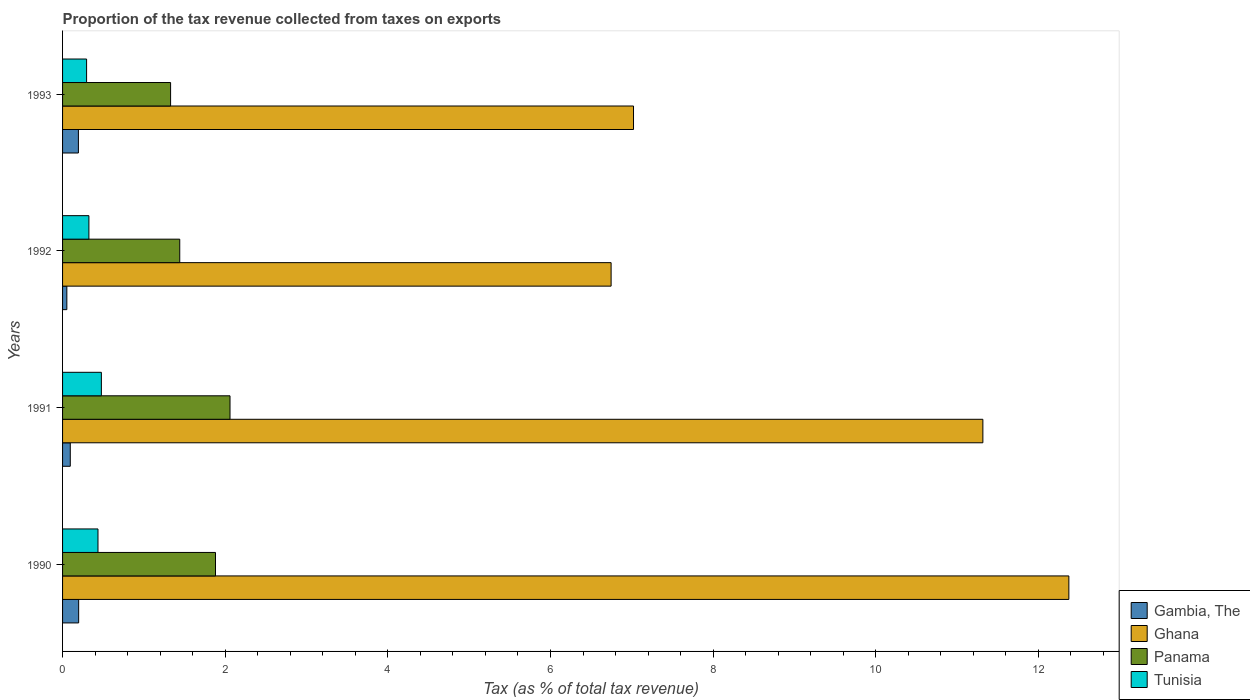Are the number of bars per tick equal to the number of legend labels?
Offer a very short reply. Yes. Are the number of bars on each tick of the Y-axis equal?
Your answer should be very brief. Yes. What is the proportion of the tax revenue collected in Ghana in 1993?
Ensure brevity in your answer.  7.02. Across all years, what is the maximum proportion of the tax revenue collected in Gambia, The?
Your answer should be compact. 0.2. Across all years, what is the minimum proportion of the tax revenue collected in Gambia, The?
Give a very brief answer. 0.05. In which year was the proportion of the tax revenue collected in Gambia, The maximum?
Your answer should be very brief. 1990. In which year was the proportion of the tax revenue collected in Gambia, The minimum?
Keep it short and to the point. 1992. What is the total proportion of the tax revenue collected in Tunisia in the graph?
Offer a terse response. 1.53. What is the difference between the proportion of the tax revenue collected in Panama in 1990 and that in 1993?
Your response must be concise. 0.55. What is the difference between the proportion of the tax revenue collected in Ghana in 1990 and the proportion of the tax revenue collected in Panama in 1992?
Keep it short and to the point. 10.93. What is the average proportion of the tax revenue collected in Panama per year?
Offer a very short reply. 1.68. In the year 1990, what is the difference between the proportion of the tax revenue collected in Gambia, The and proportion of the tax revenue collected in Panama?
Keep it short and to the point. -1.68. In how many years, is the proportion of the tax revenue collected in Panama greater than 8.4 %?
Keep it short and to the point. 0. What is the ratio of the proportion of the tax revenue collected in Ghana in 1990 to that in 1992?
Offer a very short reply. 1.83. Is the proportion of the tax revenue collected in Ghana in 1990 less than that in 1991?
Give a very brief answer. No. Is the difference between the proportion of the tax revenue collected in Gambia, The in 1990 and 1993 greater than the difference between the proportion of the tax revenue collected in Panama in 1990 and 1993?
Keep it short and to the point. No. What is the difference between the highest and the second highest proportion of the tax revenue collected in Ghana?
Provide a succinct answer. 1.06. What is the difference between the highest and the lowest proportion of the tax revenue collected in Ghana?
Your answer should be compact. 5.63. Is the sum of the proportion of the tax revenue collected in Gambia, The in 1990 and 1992 greater than the maximum proportion of the tax revenue collected in Panama across all years?
Give a very brief answer. No. What does the 2nd bar from the top in 1991 represents?
Your response must be concise. Panama. What does the 4th bar from the bottom in 1992 represents?
Provide a short and direct response. Tunisia. How many bars are there?
Your response must be concise. 16. Are all the bars in the graph horizontal?
Offer a very short reply. Yes. What is the difference between two consecutive major ticks on the X-axis?
Your answer should be compact. 2. How are the legend labels stacked?
Make the answer very short. Vertical. What is the title of the graph?
Ensure brevity in your answer.  Proportion of the tax revenue collected from taxes on exports. Does "South Sudan" appear as one of the legend labels in the graph?
Provide a succinct answer. No. What is the label or title of the X-axis?
Your answer should be very brief. Tax (as % of total tax revenue). What is the Tax (as % of total tax revenue) of Gambia, The in 1990?
Provide a short and direct response. 0.2. What is the Tax (as % of total tax revenue) in Ghana in 1990?
Your answer should be very brief. 12.37. What is the Tax (as % of total tax revenue) in Panama in 1990?
Keep it short and to the point. 1.88. What is the Tax (as % of total tax revenue) in Tunisia in 1990?
Your response must be concise. 0.44. What is the Tax (as % of total tax revenue) of Gambia, The in 1991?
Give a very brief answer. 0.09. What is the Tax (as % of total tax revenue) in Ghana in 1991?
Your answer should be compact. 11.32. What is the Tax (as % of total tax revenue) in Panama in 1991?
Your answer should be very brief. 2.06. What is the Tax (as % of total tax revenue) of Tunisia in 1991?
Provide a short and direct response. 0.48. What is the Tax (as % of total tax revenue) in Gambia, The in 1992?
Make the answer very short. 0.05. What is the Tax (as % of total tax revenue) of Ghana in 1992?
Provide a succinct answer. 6.75. What is the Tax (as % of total tax revenue) of Panama in 1992?
Your response must be concise. 1.44. What is the Tax (as % of total tax revenue) in Tunisia in 1992?
Offer a very short reply. 0.32. What is the Tax (as % of total tax revenue) in Gambia, The in 1993?
Offer a very short reply. 0.19. What is the Tax (as % of total tax revenue) of Ghana in 1993?
Give a very brief answer. 7.02. What is the Tax (as % of total tax revenue) of Panama in 1993?
Give a very brief answer. 1.33. What is the Tax (as % of total tax revenue) of Tunisia in 1993?
Give a very brief answer. 0.3. Across all years, what is the maximum Tax (as % of total tax revenue) of Gambia, The?
Your answer should be compact. 0.2. Across all years, what is the maximum Tax (as % of total tax revenue) of Ghana?
Offer a very short reply. 12.37. Across all years, what is the maximum Tax (as % of total tax revenue) in Panama?
Keep it short and to the point. 2.06. Across all years, what is the maximum Tax (as % of total tax revenue) of Tunisia?
Your answer should be very brief. 0.48. Across all years, what is the minimum Tax (as % of total tax revenue) of Gambia, The?
Your answer should be very brief. 0.05. Across all years, what is the minimum Tax (as % of total tax revenue) in Ghana?
Provide a short and direct response. 6.75. Across all years, what is the minimum Tax (as % of total tax revenue) of Panama?
Your answer should be compact. 1.33. Across all years, what is the minimum Tax (as % of total tax revenue) in Tunisia?
Offer a very short reply. 0.3. What is the total Tax (as % of total tax revenue) in Gambia, The in the graph?
Offer a very short reply. 0.54. What is the total Tax (as % of total tax revenue) of Ghana in the graph?
Provide a succinct answer. 37.46. What is the total Tax (as % of total tax revenue) in Panama in the graph?
Keep it short and to the point. 6.71. What is the total Tax (as % of total tax revenue) of Tunisia in the graph?
Your answer should be compact. 1.53. What is the difference between the Tax (as % of total tax revenue) in Gambia, The in 1990 and that in 1991?
Keep it short and to the point. 0.1. What is the difference between the Tax (as % of total tax revenue) in Ghana in 1990 and that in 1991?
Give a very brief answer. 1.06. What is the difference between the Tax (as % of total tax revenue) of Panama in 1990 and that in 1991?
Your answer should be very brief. -0.18. What is the difference between the Tax (as % of total tax revenue) of Tunisia in 1990 and that in 1991?
Provide a short and direct response. -0.04. What is the difference between the Tax (as % of total tax revenue) of Gambia, The in 1990 and that in 1992?
Your answer should be very brief. 0.15. What is the difference between the Tax (as % of total tax revenue) of Ghana in 1990 and that in 1992?
Your response must be concise. 5.63. What is the difference between the Tax (as % of total tax revenue) of Panama in 1990 and that in 1992?
Make the answer very short. 0.44. What is the difference between the Tax (as % of total tax revenue) in Tunisia in 1990 and that in 1992?
Provide a short and direct response. 0.11. What is the difference between the Tax (as % of total tax revenue) in Gambia, The in 1990 and that in 1993?
Your answer should be compact. 0. What is the difference between the Tax (as % of total tax revenue) of Ghana in 1990 and that in 1993?
Keep it short and to the point. 5.35. What is the difference between the Tax (as % of total tax revenue) in Panama in 1990 and that in 1993?
Your answer should be very brief. 0.55. What is the difference between the Tax (as % of total tax revenue) of Tunisia in 1990 and that in 1993?
Give a very brief answer. 0.14. What is the difference between the Tax (as % of total tax revenue) of Gambia, The in 1991 and that in 1992?
Your answer should be compact. 0.04. What is the difference between the Tax (as % of total tax revenue) in Ghana in 1991 and that in 1992?
Give a very brief answer. 4.57. What is the difference between the Tax (as % of total tax revenue) of Panama in 1991 and that in 1992?
Provide a short and direct response. 0.62. What is the difference between the Tax (as % of total tax revenue) in Tunisia in 1991 and that in 1992?
Your answer should be compact. 0.15. What is the difference between the Tax (as % of total tax revenue) of Ghana in 1991 and that in 1993?
Keep it short and to the point. 4.3. What is the difference between the Tax (as % of total tax revenue) in Panama in 1991 and that in 1993?
Provide a succinct answer. 0.73. What is the difference between the Tax (as % of total tax revenue) of Tunisia in 1991 and that in 1993?
Keep it short and to the point. 0.18. What is the difference between the Tax (as % of total tax revenue) of Gambia, The in 1992 and that in 1993?
Give a very brief answer. -0.14. What is the difference between the Tax (as % of total tax revenue) of Ghana in 1992 and that in 1993?
Your answer should be very brief. -0.28. What is the difference between the Tax (as % of total tax revenue) of Panama in 1992 and that in 1993?
Keep it short and to the point. 0.11. What is the difference between the Tax (as % of total tax revenue) of Tunisia in 1992 and that in 1993?
Provide a succinct answer. 0.03. What is the difference between the Tax (as % of total tax revenue) of Gambia, The in 1990 and the Tax (as % of total tax revenue) of Ghana in 1991?
Keep it short and to the point. -11.12. What is the difference between the Tax (as % of total tax revenue) of Gambia, The in 1990 and the Tax (as % of total tax revenue) of Panama in 1991?
Your response must be concise. -1.86. What is the difference between the Tax (as % of total tax revenue) of Gambia, The in 1990 and the Tax (as % of total tax revenue) of Tunisia in 1991?
Offer a very short reply. -0.28. What is the difference between the Tax (as % of total tax revenue) in Ghana in 1990 and the Tax (as % of total tax revenue) in Panama in 1991?
Offer a very short reply. 10.32. What is the difference between the Tax (as % of total tax revenue) in Ghana in 1990 and the Tax (as % of total tax revenue) in Tunisia in 1991?
Provide a succinct answer. 11.9. What is the difference between the Tax (as % of total tax revenue) of Panama in 1990 and the Tax (as % of total tax revenue) of Tunisia in 1991?
Make the answer very short. 1.4. What is the difference between the Tax (as % of total tax revenue) of Gambia, The in 1990 and the Tax (as % of total tax revenue) of Ghana in 1992?
Offer a terse response. -6.55. What is the difference between the Tax (as % of total tax revenue) in Gambia, The in 1990 and the Tax (as % of total tax revenue) in Panama in 1992?
Your answer should be very brief. -1.24. What is the difference between the Tax (as % of total tax revenue) of Gambia, The in 1990 and the Tax (as % of total tax revenue) of Tunisia in 1992?
Your answer should be compact. -0.13. What is the difference between the Tax (as % of total tax revenue) in Ghana in 1990 and the Tax (as % of total tax revenue) in Panama in 1992?
Give a very brief answer. 10.93. What is the difference between the Tax (as % of total tax revenue) of Ghana in 1990 and the Tax (as % of total tax revenue) of Tunisia in 1992?
Your answer should be very brief. 12.05. What is the difference between the Tax (as % of total tax revenue) of Panama in 1990 and the Tax (as % of total tax revenue) of Tunisia in 1992?
Your response must be concise. 1.56. What is the difference between the Tax (as % of total tax revenue) of Gambia, The in 1990 and the Tax (as % of total tax revenue) of Ghana in 1993?
Ensure brevity in your answer.  -6.82. What is the difference between the Tax (as % of total tax revenue) in Gambia, The in 1990 and the Tax (as % of total tax revenue) in Panama in 1993?
Keep it short and to the point. -1.13. What is the difference between the Tax (as % of total tax revenue) in Gambia, The in 1990 and the Tax (as % of total tax revenue) in Tunisia in 1993?
Offer a terse response. -0.1. What is the difference between the Tax (as % of total tax revenue) in Ghana in 1990 and the Tax (as % of total tax revenue) in Panama in 1993?
Keep it short and to the point. 11.05. What is the difference between the Tax (as % of total tax revenue) of Ghana in 1990 and the Tax (as % of total tax revenue) of Tunisia in 1993?
Ensure brevity in your answer.  12.08. What is the difference between the Tax (as % of total tax revenue) in Panama in 1990 and the Tax (as % of total tax revenue) in Tunisia in 1993?
Make the answer very short. 1.59. What is the difference between the Tax (as % of total tax revenue) of Gambia, The in 1991 and the Tax (as % of total tax revenue) of Ghana in 1992?
Your response must be concise. -6.65. What is the difference between the Tax (as % of total tax revenue) in Gambia, The in 1991 and the Tax (as % of total tax revenue) in Panama in 1992?
Your answer should be very brief. -1.35. What is the difference between the Tax (as % of total tax revenue) of Gambia, The in 1991 and the Tax (as % of total tax revenue) of Tunisia in 1992?
Provide a succinct answer. -0.23. What is the difference between the Tax (as % of total tax revenue) in Ghana in 1991 and the Tax (as % of total tax revenue) in Panama in 1992?
Give a very brief answer. 9.88. What is the difference between the Tax (as % of total tax revenue) in Ghana in 1991 and the Tax (as % of total tax revenue) in Tunisia in 1992?
Give a very brief answer. 10.99. What is the difference between the Tax (as % of total tax revenue) of Panama in 1991 and the Tax (as % of total tax revenue) of Tunisia in 1992?
Your response must be concise. 1.74. What is the difference between the Tax (as % of total tax revenue) of Gambia, The in 1991 and the Tax (as % of total tax revenue) of Ghana in 1993?
Offer a very short reply. -6.93. What is the difference between the Tax (as % of total tax revenue) in Gambia, The in 1991 and the Tax (as % of total tax revenue) in Panama in 1993?
Offer a very short reply. -1.23. What is the difference between the Tax (as % of total tax revenue) in Gambia, The in 1991 and the Tax (as % of total tax revenue) in Tunisia in 1993?
Make the answer very short. -0.2. What is the difference between the Tax (as % of total tax revenue) of Ghana in 1991 and the Tax (as % of total tax revenue) of Panama in 1993?
Offer a very short reply. 9.99. What is the difference between the Tax (as % of total tax revenue) of Ghana in 1991 and the Tax (as % of total tax revenue) of Tunisia in 1993?
Make the answer very short. 11.02. What is the difference between the Tax (as % of total tax revenue) of Panama in 1991 and the Tax (as % of total tax revenue) of Tunisia in 1993?
Make the answer very short. 1.76. What is the difference between the Tax (as % of total tax revenue) in Gambia, The in 1992 and the Tax (as % of total tax revenue) in Ghana in 1993?
Make the answer very short. -6.97. What is the difference between the Tax (as % of total tax revenue) in Gambia, The in 1992 and the Tax (as % of total tax revenue) in Panama in 1993?
Offer a very short reply. -1.28. What is the difference between the Tax (as % of total tax revenue) of Gambia, The in 1992 and the Tax (as % of total tax revenue) of Tunisia in 1993?
Provide a short and direct response. -0.24. What is the difference between the Tax (as % of total tax revenue) in Ghana in 1992 and the Tax (as % of total tax revenue) in Panama in 1993?
Provide a succinct answer. 5.42. What is the difference between the Tax (as % of total tax revenue) in Ghana in 1992 and the Tax (as % of total tax revenue) in Tunisia in 1993?
Provide a short and direct response. 6.45. What is the difference between the Tax (as % of total tax revenue) in Panama in 1992 and the Tax (as % of total tax revenue) in Tunisia in 1993?
Offer a terse response. 1.15. What is the average Tax (as % of total tax revenue) of Gambia, The per year?
Give a very brief answer. 0.14. What is the average Tax (as % of total tax revenue) of Ghana per year?
Keep it short and to the point. 9.36. What is the average Tax (as % of total tax revenue) in Panama per year?
Make the answer very short. 1.68. What is the average Tax (as % of total tax revenue) in Tunisia per year?
Your answer should be compact. 0.38. In the year 1990, what is the difference between the Tax (as % of total tax revenue) in Gambia, The and Tax (as % of total tax revenue) in Ghana?
Provide a succinct answer. -12.18. In the year 1990, what is the difference between the Tax (as % of total tax revenue) in Gambia, The and Tax (as % of total tax revenue) in Panama?
Keep it short and to the point. -1.68. In the year 1990, what is the difference between the Tax (as % of total tax revenue) in Gambia, The and Tax (as % of total tax revenue) in Tunisia?
Make the answer very short. -0.24. In the year 1990, what is the difference between the Tax (as % of total tax revenue) in Ghana and Tax (as % of total tax revenue) in Panama?
Offer a terse response. 10.49. In the year 1990, what is the difference between the Tax (as % of total tax revenue) of Ghana and Tax (as % of total tax revenue) of Tunisia?
Give a very brief answer. 11.94. In the year 1990, what is the difference between the Tax (as % of total tax revenue) in Panama and Tax (as % of total tax revenue) in Tunisia?
Offer a terse response. 1.45. In the year 1991, what is the difference between the Tax (as % of total tax revenue) in Gambia, The and Tax (as % of total tax revenue) in Ghana?
Offer a very short reply. -11.22. In the year 1991, what is the difference between the Tax (as % of total tax revenue) in Gambia, The and Tax (as % of total tax revenue) in Panama?
Offer a terse response. -1.96. In the year 1991, what is the difference between the Tax (as % of total tax revenue) of Gambia, The and Tax (as % of total tax revenue) of Tunisia?
Give a very brief answer. -0.38. In the year 1991, what is the difference between the Tax (as % of total tax revenue) in Ghana and Tax (as % of total tax revenue) in Panama?
Ensure brevity in your answer.  9.26. In the year 1991, what is the difference between the Tax (as % of total tax revenue) of Ghana and Tax (as % of total tax revenue) of Tunisia?
Keep it short and to the point. 10.84. In the year 1991, what is the difference between the Tax (as % of total tax revenue) in Panama and Tax (as % of total tax revenue) in Tunisia?
Your answer should be very brief. 1.58. In the year 1992, what is the difference between the Tax (as % of total tax revenue) in Gambia, The and Tax (as % of total tax revenue) in Ghana?
Provide a succinct answer. -6.69. In the year 1992, what is the difference between the Tax (as % of total tax revenue) in Gambia, The and Tax (as % of total tax revenue) in Panama?
Your response must be concise. -1.39. In the year 1992, what is the difference between the Tax (as % of total tax revenue) in Gambia, The and Tax (as % of total tax revenue) in Tunisia?
Provide a succinct answer. -0.27. In the year 1992, what is the difference between the Tax (as % of total tax revenue) of Ghana and Tax (as % of total tax revenue) of Panama?
Provide a short and direct response. 5.3. In the year 1992, what is the difference between the Tax (as % of total tax revenue) in Ghana and Tax (as % of total tax revenue) in Tunisia?
Offer a very short reply. 6.42. In the year 1992, what is the difference between the Tax (as % of total tax revenue) of Panama and Tax (as % of total tax revenue) of Tunisia?
Give a very brief answer. 1.12. In the year 1993, what is the difference between the Tax (as % of total tax revenue) of Gambia, The and Tax (as % of total tax revenue) of Ghana?
Your answer should be compact. -6.83. In the year 1993, what is the difference between the Tax (as % of total tax revenue) in Gambia, The and Tax (as % of total tax revenue) in Panama?
Give a very brief answer. -1.13. In the year 1993, what is the difference between the Tax (as % of total tax revenue) of Gambia, The and Tax (as % of total tax revenue) of Tunisia?
Keep it short and to the point. -0.1. In the year 1993, what is the difference between the Tax (as % of total tax revenue) of Ghana and Tax (as % of total tax revenue) of Panama?
Offer a very short reply. 5.69. In the year 1993, what is the difference between the Tax (as % of total tax revenue) of Ghana and Tax (as % of total tax revenue) of Tunisia?
Keep it short and to the point. 6.73. In the year 1993, what is the difference between the Tax (as % of total tax revenue) of Panama and Tax (as % of total tax revenue) of Tunisia?
Your response must be concise. 1.03. What is the ratio of the Tax (as % of total tax revenue) in Gambia, The in 1990 to that in 1991?
Your response must be concise. 2.09. What is the ratio of the Tax (as % of total tax revenue) in Ghana in 1990 to that in 1991?
Provide a short and direct response. 1.09. What is the ratio of the Tax (as % of total tax revenue) of Panama in 1990 to that in 1991?
Make the answer very short. 0.91. What is the ratio of the Tax (as % of total tax revenue) of Tunisia in 1990 to that in 1991?
Provide a succinct answer. 0.91. What is the ratio of the Tax (as % of total tax revenue) in Gambia, The in 1990 to that in 1992?
Your response must be concise. 3.76. What is the ratio of the Tax (as % of total tax revenue) of Ghana in 1990 to that in 1992?
Your response must be concise. 1.83. What is the ratio of the Tax (as % of total tax revenue) in Panama in 1990 to that in 1992?
Make the answer very short. 1.3. What is the ratio of the Tax (as % of total tax revenue) in Tunisia in 1990 to that in 1992?
Keep it short and to the point. 1.34. What is the ratio of the Tax (as % of total tax revenue) in Gambia, The in 1990 to that in 1993?
Make the answer very short. 1.02. What is the ratio of the Tax (as % of total tax revenue) of Ghana in 1990 to that in 1993?
Keep it short and to the point. 1.76. What is the ratio of the Tax (as % of total tax revenue) of Panama in 1990 to that in 1993?
Make the answer very short. 1.42. What is the ratio of the Tax (as % of total tax revenue) of Tunisia in 1990 to that in 1993?
Make the answer very short. 1.47. What is the ratio of the Tax (as % of total tax revenue) of Gambia, The in 1991 to that in 1992?
Offer a terse response. 1.8. What is the ratio of the Tax (as % of total tax revenue) of Ghana in 1991 to that in 1992?
Offer a terse response. 1.68. What is the ratio of the Tax (as % of total tax revenue) of Panama in 1991 to that in 1992?
Keep it short and to the point. 1.43. What is the ratio of the Tax (as % of total tax revenue) of Tunisia in 1991 to that in 1992?
Provide a succinct answer. 1.47. What is the ratio of the Tax (as % of total tax revenue) in Gambia, The in 1991 to that in 1993?
Offer a very short reply. 0.49. What is the ratio of the Tax (as % of total tax revenue) of Ghana in 1991 to that in 1993?
Keep it short and to the point. 1.61. What is the ratio of the Tax (as % of total tax revenue) of Panama in 1991 to that in 1993?
Your answer should be very brief. 1.55. What is the ratio of the Tax (as % of total tax revenue) in Tunisia in 1991 to that in 1993?
Give a very brief answer. 1.62. What is the ratio of the Tax (as % of total tax revenue) in Gambia, The in 1992 to that in 1993?
Provide a succinct answer. 0.27. What is the ratio of the Tax (as % of total tax revenue) of Ghana in 1992 to that in 1993?
Ensure brevity in your answer.  0.96. What is the ratio of the Tax (as % of total tax revenue) of Panama in 1992 to that in 1993?
Your answer should be very brief. 1.08. What is the ratio of the Tax (as % of total tax revenue) of Tunisia in 1992 to that in 1993?
Your answer should be compact. 1.1. What is the difference between the highest and the second highest Tax (as % of total tax revenue) in Gambia, The?
Your answer should be compact. 0. What is the difference between the highest and the second highest Tax (as % of total tax revenue) in Ghana?
Offer a very short reply. 1.06. What is the difference between the highest and the second highest Tax (as % of total tax revenue) of Panama?
Your response must be concise. 0.18. What is the difference between the highest and the second highest Tax (as % of total tax revenue) in Tunisia?
Ensure brevity in your answer.  0.04. What is the difference between the highest and the lowest Tax (as % of total tax revenue) in Gambia, The?
Your answer should be very brief. 0.15. What is the difference between the highest and the lowest Tax (as % of total tax revenue) of Ghana?
Offer a terse response. 5.63. What is the difference between the highest and the lowest Tax (as % of total tax revenue) in Panama?
Offer a very short reply. 0.73. What is the difference between the highest and the lowest Tax (as % of total tax revenue) in Tunisia?
Your answer should be very brief. 0.18. 